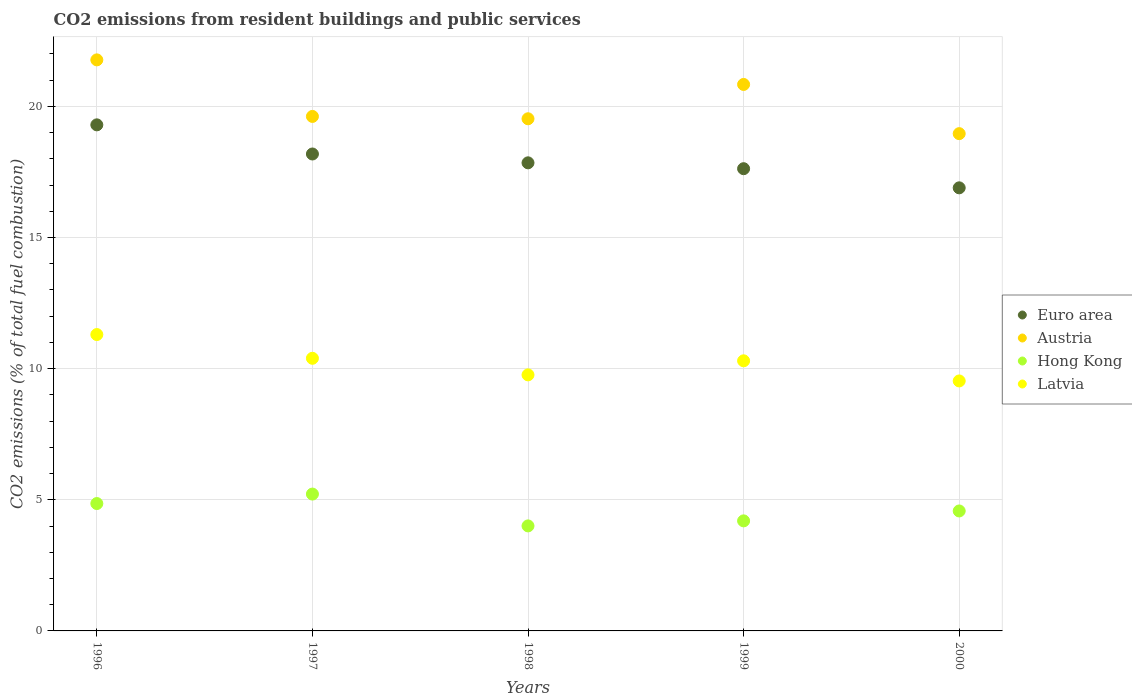How many different coloured dotlines are there?
Your answer should be compact. 4. Is the number of dotlines equal to the number of legend labels?
Offer a very short reply. Yes. What is the total CO2 emitted in Hong Kong in 1999?
Provide a short and direct response. 4.2. Across all years, what is the maximum total CO2 emitted in Latvia?
Offer a very short reply. 11.3. Across all years, what is the minimum total CO2 emitted in Euro area?
Your answer should be compact. 16.89. In which year was the total CO2 emitted in Hong Kong minimum?
Keep it short and to the point. 1998. What is the total total CO2 emitted in Hong Kong in the graph?
Provide a succinct answer. 22.85. What is the difference between the total CO2 emitted in Austria in 1996 and that in 2000?
Provide a succinct answer. 2.81. What is the difference between the total CO2 emitted in Austria in 1999 and the total CO2 emitted in Latvia in 2000?
Make the answer very short. 11.3. What is the average total CO2 emitted in Latvia per year?
Provide a succinct answer. 10.26. In the year 1997, what is the difference between the total CO2 emitted in Hong Kong and total CO2 emitted in Austria?
Offer a very short reply. -14.4. In how many years, is the total CO2 emitted in Latvia greater than 13?
Your answer should be very brief. 0. What is the ratio of the total CO2 emitted in Latvia in 1997 to that in 2000?
Offer a terse response. 1.09. Is the total CO2 emitted in Hong Kong in 1996 less than that in 1998?
Make the answer very short. No. What is the difference between the highest and the second highest total CO2 emitted in Latvia?
Your answer should be very brief. 0.91. What is the difference between the highest and the lowest total CO2 emitted in Latvia?
Provide a succinct answer. 1.77. Is the sum of the total CO2 emitted in Latvia in 1998 and 1999 greater than the maximum total CO2 emitted in Hong Kong across all years?
Offer a terse response. Yes. Is it the case that in every year, the sum of the total CO2 emitted in Austria and total CO2 emitted in Euro area  is greater than the total CO2 emitted in Latvia?
Your answer should be compact. Yes. Does the total CO2 emitted in Latvia monotonically increase over the years?
Your answer should be very brief. No. Is the total CO2 emitted in Euro area strictly greater than the total CO2 emitted in Latvia over the years?
Keep it short and to the point. Yes. Is the total CO2 emitted in Latvia strictly less than the total CO2 emitted in Euro area over the years?
Provide a succinct answer. Yes. How many dotlines are there?
Provide a short and direct response. 4. How many years are there in the graph?
Offer a terse response. 5. Does the graph contain any zero values?
Your response must be concise. No. How many legend labels are there?
Provide a short and direct response. 4. How are the legend labels stacked?
Offer a very short reply. Vertical. What is the title of the graph?
Offer a very short reply. CO2 emissions from resident buildings and public services. What is the label or title of the Y-axis?
Your response must be concise. CO2 emissions (% of total fuel combustion). What is the CO2 emissions (% of total fuel combustion) in Euro area in 1996?
Provide a short and direct response. 19.29. What is the CO2 emissions (% of total fuel combustion) in Austria in 1996?
Make the answer very short. 21.77. What is the CO2 emissions (% of total fuel combustion) in Hong Kong in 1996?
Your answer should be compact. 4.86. What is the CO2 emissions (% of total fuel combustion) of Latvia in 1996?
Your answer should be compact. 11.3. What is the CO2 emissions (% of total fuel combustion) in Euro area in 1997?
Your response must be concise. 18.18. What is the CO2 emissions (% of total fuel combustion) in Austria in 1997?
Offer a very short reply. 19.62. What is the CO2 emissions (% of total fuel combustion) of Hong Kong in 1997?
Keep it short and to the point. 5.22. What is the CO2 emissions (% of total fuel combustion) of Latvia in 1997?
Make the answer very short. 10.39. What is the CO2 emissions (% of total fuel combustion) of Euro area in 1998?
Keep it short and to the point. 17.85. What is the CO2 emissions (% of total fuel combustion) in Austria in 1998?
Give a very brief answer. 19.53. What is the CO2 emissions (% of total fuel combustion) of Hong Kong in 1998?
Provide a succinct answer. 4. What is the CO2 emissions (% of total fuel combustion) of Latvia in 1998?
Offer a terse response. 9.76. What is the CO2 emissions (% of total fuel combustion) of Euro area in 1999?
Give a very brief answer. 17.62. What is the CO2 emissions (% of total fuel combustion) in Austria in 1999?
Make the answer very short. 20.83. What is the CO2 emissions (% of total fuel combustion) of Hong Kong in 1999?
Make the answer very short. 4.2. What is the CO2 emissions (% of total fuel combustion) of Latvia in 1999?
Your answer should be very brief. 10.3. What is the CO2 emissions (% of total fuel combustion) of Euro area in 2000?
Provide a short and direct response. 16.89. What is the CO2 emissions (% of total fuel combustion) in Austria in 2000?
Provide a short and direct response. 18.96. What is the CO2 emissions (% of total fuel combustion) in Hong Kong in 2000?
Your response must be concise. 4.57. What is the CO2 emissions (% of total fuel combustion) of Latvia in 2000?
Offer a terse response. 9.53. Across all years, what is the maximum CO2 emissions (% of total fuel combustion) in Euro area?
Give a very brief answer. 19.29. Across all years, what is the maximum CO2 emissions (% of total fuel combustion) in Austria?
Your answer should be very brief. 21.77. Across all years, what is the maximum CO2 emissions (% of total fuel combustion) of Hong Kong?
Give a very brief answer. 5.22. Across all years, what is the maximum CO2 emissions (% of total fuel combustion) of Latvia?
Provide a short and direct response. 11.3. Across all years, what is the minimum CO2 emissions (% of total fuel combustion) of Euro area?
Give a very brief answer. 16.89. Across all years, what is the minimum CO2 emissions (% of total fuel combustion) in Austria?
Your response must be concise. 18.96. Across all years, what is the minimum CO2 emissions (% of total fuel combustion) of Hong Kong?
Make the answer very short. 4. Across all years, what is the minimum CO2 emissions (% of total fuel combustion) of Latvia?
Offer a very short reply. 9.53. What is the total CO2 emissions (% of total fuel combustion) of Euro area in the graph?
Keep it short and to the point. 89.84. What is the total CO2 emissions (% of total fuel combustion) of Austria in the graph?
Provide a short and direct response. 100.71. What is the total CO2 emissions (% of total fuel combustion) in Hong Kong in the graph?
Offer a terse response. 22.85. What is the total CO2 emissions (% of total fuel combustion) of Latvia in the graph?
Give a very brief answer. 51.28. What is the difference between the CO2 emissions (% of total fuel combustion) in Euro area in 1996 and that in 1997?
Provide a succinct answer. 1.11. What is the difference between the CO2 emissions (% of total fuel combustion) in Austria in 1996 and that in 1997?
Offer a terse response. 2.16. What is the difference between the CO2 emissions (% of total fuel combustion) of Hong Kong in 1996 and that in 1997?
Give a very brief answer. -0.36. What is the difference between the CO2 emissions (% of total fuel combustion) in Latvia in 1996 and that in 1997?
Your answer should be very brief. 0.91. What is the difference between the CO2 emissions (% of total fuel combustion) of Euro area in 1996 and that in 1998?
Offer a very short reply. 1.45. What is the difference between the CO2 emissions (% of total fuel combustion) in Austria in 1996 and that in 1998?
Provide a succinct answer. 2.25. What is the difference between the CO2 emissions (% of total fuel combustion) in Hong Kong in 1996 and that in 1998?
Ensure brevity in your answer.  0.85. What is the difference between the CO2 emissions (% of total fuel combustion) in Latvia in 1996 and that in 1998?
Provide a short and direct response. 1.54. What is the difference between the CO2 emissions (% of total fuel combustion) of Euro area in 1996 and that in 1999?
Provide a short and direct response. 1.67. What is the difference between the CO2 emissions (% of total fuel combustion) in Austria in 1996 and that in 1999?
Keep it short and to the point. 0.94. What is the difference between the CO2 emissions (% of total fuel combustion) in Hong Kong in 1996 and that in 1999?
Make the answer very short. 0.66. What is the difference between the CO2 emissions (% of total fuel combustion) of Euro area in 1996 and that in 2000?
Your response must be concise. 2.4. What is the difference between the CO2 emissions (% of total fuel combustion) of Austria in 1996 and that in 2000?
Offer a very short reply. 2.81. What is the difference between the CO2 emissions (% of total fuel combustion) in Hong Kong in 1996 and that in 2000?
Give a very brief answer. 0.28. What is the difference between the CO2 emissions (% of total fuel combustion) in Latvia in 1996 and that in 2000?
Keep it short and to the point. 1.77. What is the difference between the CO2 emissions (% of total fuel combustion) in Euro area in 1997 and that in 1998?
Your answer should be very brief. 0.34. What is the difference between the CO2 emissions (% of total fuel combustion) of Austria in 1997 and that in 1998?
Keep it short and to the point. 0.09. What is the difference between the CO2 emissions (% of total fuel combustion) in Hong Kong in 1997 and that in 1998?
Give a very brief answer. 1.21. What is the difference between the CO2 emissions (% of total fuel combustion) in Latvia in 1997 and that in 1998?
Ensure brevity in your answer.  0.63. What is the difference between the CO2 emissions (% of total fuel combustion) of Euro area in 1997 and that in 1999?
Offer a terse response. 0.56. What is the difference between the CO2 emissions (% of total fuel combustion) in Austria in 1997 and that in 1999?
Keep it short and to the point. -1.22. What is the difference between the CO2 emissions (% of total fuel combustion) of Hong Kong in 1997 and that in 1999?
Keep it short and to the point. 1.02. What is the difference between the CO2 emissions (% of total fuel combustion) of Latvia in 1997 and that in 1999?
Provide a succinct answer. 0.1. What is the difference between the CO2 emissions (% of total fuel combustion) in Euro area in 1997 and that in 2000?
Provide a short and direct response. 1.29. What is the difference between the CO2 emissions (% of total fuel combustion) of Austria in 1997 and that in 2000?
Your response must be concise. 0.66. What is the difference between the CO2 emissions (% of total fuel combustion) in Hong Kong in 1997 and that in 2000?
Give a very brief answer. 0.64. What is the difference between the CO2 emissions (% of total fuel combustion) of Latvia in 1997 and that in 2000?
Offer a terse response. 0.86. What is the difference between the CO2 emissions (% of total fuel combustion) of Euro area in 1998 and that in 1999?
Offer a terse response. 0.22. What is the difference between the CO2 emissions (% of total fuel combustion) in Austria in 1998 and that in 1999?
Ensure brevity in your answer.  -1.31. What is the difference between the CO2 emissions (% of total fuel combustion) of Hong Kong in 1998 and that in 1999?
Make the answer very short. -0.19. What is the difference between the CO2 emissions (% of total fuel combustion) of Latvia in 1998 and that in 1999?
Make the answer very short. -0.54. What is the difference between the CO2 emissions (% of total fuel combustion) of Euro area in 1998 and that in 2000?
Give a very brief answer. 0.95. What is the difference between the CO2 emissions (% of total fuel combustion) of Austria in 1998 and that in 2000?
Provide a succinct answer. 0.57. What is the difference between the CO2 emissions (% of total fuel combustion) in Hong Kong in 1998 and that in 2000?
Ensure brevity in your answer.  -0.57. What is the difference between the CO2 emissions (% of total fuel combustion) in Latvia in 1998 and that in 2000?
Provide a short and direct response. 0.23. What is the difference between the CO2 emissions (% of total fuel combustion) of Euro area in 1999 and that in 2000?
Make the answer very short. 0.73. What is the difference between the CO2 emissions (% of total fuel combustion) in Austria in 1999 and that in 2000?
Your answer should be compact. 1.88. What is the difference between the CO2 emissions (% of total fuel combustion) of Hong Kong in 1999 and that in 2000?
Your answer should be compact. -0.38. What is the difference between the CO2 emissions (% of total fuel combustion) of Latvia in 1999 and that in 2000?
Offer a very short reply. 0.77. What is the difference between the CO2 emissions (% of total fuel combustion) of Euro area in 1996 and the CO2 emissions (% of total fuel combustion) of Austria in 1997?
Your answer should be compact. -0.32. What is the difference between the CO2 emissions (% of total fuel combustion) of Euro area in 1996 and the CO2 emissions (% of total fuel combustion) of Hong Kong in 1997?
Make the answer very short. 14.08. What is the difference between the CO2 emissions (% of total fuel combustion) of Euro area in 1996 and the CO2 emissions (% of total fuel combustion) of Latvia in 1997?
Keep it short and to the point. 8.9. What is the difference between the CO2 emissions (% of total fuel combustion) in Austria in 1996 and the CO2 emissions (% of total fuel combustion) in Hong Kong in 1997?
Your answer should be very brief. 16.55. What is the difference between the CO2 emissions (% of total fuel combustion) of Austria in 1996 and the CO2 emissions (% of total fuel combustion) of Latvia in 1997?
Offer a terse response. 11.38. What is the difference between the CO2 emissions (% of total fuel combustion) of Hong Kong in 1996 and the CO2 emissions (% of total fuel combustion) of Latvia in 1997?
Provide a succinct answer. -5.54. What is the difference between the CO2 emissions (% of total fuel combustion) of Euro area in 1996 and the CO2 emissions (% of total fuel combustion) of Austria in 1998?
Offer a very short reply. -0.23. What is the difference between the CO2 emissions (% of total fuel combustion) of Euro area in 1996 and the CO2 emissions (% of total fuel combustion) of Hong Kong in 1998?
Offer a very short reply. 15.29. What is the difference between the CO2 emissions (% of total fuel combustion) of Euro area in 1996 and the CO2 emissions (% of total fuel combustion) of Latvia in 1998?
Keep it short and to the point. 9.53. What is the difference between the CO2 emissions (% of total fuel combustion) in Austria in 1996 and the CO2 emissions (% of total fuel combustion) in Hong Kong in 1998?
Ensure brevity in your answer.  17.77. What is the difference between the CO2 emissions (% of total fuel combustion) of Austria in 1996 and the CO2 emissions (% of total fuel combustion) of Latvia in 1998?
Provide a succinct answer. 12.01. What is the difference between the CO2 emissions (% of total fuel combustion) in Hong Kong in 1996 and the CO2 emissions (% of total fuel combustion) in Latvia in 1998?
Keep it short and to the point. -4.91. What is the difference between the CO2 emissions (% of total fuel combustion) of Euro area in 1996 and the CO2 emissions (% of total fuel combustion) of Austria in 1999?
Offer a very short reply. -1.54. What is the difference between the CO2 emissions (% of total fuel combustion) of Euro area in 1996 and the CO2 emissions (% of total fuel combustion) of Hong Kong in 1999?
Keep it short and to the point. 15.1. What is the difference between the CO2 emissions (% of total fuel combustion) of Euro area in 1996 and the CO2 emissions (% of total fuel combustion) of Latvia in 1999?
Provide a short and direct response. 9. What is the difference between the CO2 emissions (% of total fuel combustion) of Austria in 1996 and the CO2 emissions (% of total fuel combustion) of Hong Kong in 1999?
Keep it short and to the point. 17.58. What is the difference between the CO2 emissions (% of total fuel combustion) of Austria in 1996 and the CO2 emissions (% of total fuel combustion) of Latvia in 1999?
Your response must be concise. 11.47. What is the difference between the CO2 emissions (% of total fuel combustion) in Hong Kong in 1996 and the CO2 emissions (% of total fuel combustion) in Latvia in 1999?
Ensure brevity in your answer.  -5.44. What is the difference between the CO2 emissions (% of total fuel combustion) of Euro area in 1996 and the CO2 emissions (% of total fuel combustion) of Austria in 2000?
Give a very brief answer. 0.34. What is the difference between the CO2 emissions (% of total fuel combustion) of Euro area in 1996 and the CO2 emissions (% of total fuel combustion) of Hong Kong in 2000?
Offer a very short reply. 14.72. What is the difference between the CO2 emissions (% of total fuel combustion) of Euro area in 1996 and the CO2 emissions (% of total fuel combustion) of Latvia in 2000?
Offer a terse response. 9.76. What is the difference between the CO2 emissions (% of total fuel combustion) of Austria in 1996 and the CO2 emissions (% of total fuel combustion) of Hong Kong in 2000?
Provide a short and direct response. 17.2. What is the difference between the CO2 emissions (% of total fuel combustion) of Austria in 1996 and the CO2 emissions (% of total fuel combustion) of Latvia in 2000?
Your answer should be compact. 12.24. What is the difference between the CO2 emissions (% of total fuel combustion) of Hong Kong in 1996 and the CO2 emissions (% of total fuel combustion) of Latvia in 2000?
Give a very brief answer. -4.67. What is the difference between the CO2 emissions (% of total fuel combustion) of Euro area in 1997 and the CO2 emissions (% of total fuel combustion) of Austria in 1998?
Offer a very short reply. -1.34. What is the difference between the CO2 emissions (% of total fuel combustion) in Euro area in 1997 and the CO2 emissions (% of total fuel combustion) in Hong Kong in 1998?
Your answer should be very brief. 14.18. What is the difference between the CO2 emissions (% of total fuel combustion) of Euro area in 1997 and the CO2 emissions (% of total fuel combustion) of Latvia in 1998?
Make the answer very short. 8.42. What is the difference between the CO2 emissions (% of total fuel combustion) of Austria in 1997 and the CO2 emissions (% of total fuel combustion) of Hong Kong in 1998?
Provide a succinct answer. 15.61. What is the difference between the CO2 emissions (% of total fuel combustion) of Austria in 1997 and the CO2 emissions (% of total fuel combustion) of Latvia in 1998?
Your answer should be compact. 9.85. What is the difference between the CO2 emissions (% of total fuel combustion) of Hong Kong in 1997 and the CO2 emissions (% of total fuel combustion) of Latvia in 1998?
Make the answer very short. -4.54. What is the difference between the CO2 emissions (% of total fuel combustion) of Euro area in 1997 and the CO2 emissions (% of total fuel combustion) of Austria in 1999?
Ensure brevity in your answer.  -2.65. What is the difference between the CO2 emissions (% of total fuel combustion) of Euro area in 1997 and the CO2 emissions (% of total fuel combustion) of Hong Kong in 1999?
Provide a succinct answer. 13.99. What is the difference between the CO2 emissions (% of total fuel combustion) of Euro area in 1997 and the CO2 emissions (% of total fuel combustion) of Latvia in 1999?
Offer a very short reply. 7.89. What is the difference between the CO2 emissions (% of total fuel combustion) of Austria in 1997 and the CO2 emissions (% of total fuel combustion) of Hong Kong in 1999?
Offer a very short reply. 15.42. What is the difference between the CO2 emissions (% of total fuel combustion) in Austria in 1997 and the CO2 emissions (% of total fuel combustion) in Latvia in 1999?
Make the answer very short. 9.32. What is the difference between the CO2 emissions (% of total fuel combustion) in Hong Kong in 1997 and the CO2 emissions (% of total fuel combustion) in Latvia in 1999?
Keep it short and to the point. -5.08. What is the difference between the CO2 emissions (% of total fuel combustion) in Euro area in 1997 and the CO2 emissions (% of total fuel combustion) in Austria in 2000?
Provide a short and direct response. -0.78. What is the difference between the CO2 emissions (% of total fuel combustion) in Euro area in 1997 and the CO2 emissions (% of total fuel combustion) in Hong Kong in 2000?
Ensure brevity in your answer.  13.61. What is the difference between the CO2 emissions (% of total fuel combustion) in Euro area in 1997 and the CO2 emissions (% of total fuel combustion) in Latvia in 2000?
Your answer should be very brief. 8.65. What is the difference between the CO2 emissions (% of total fuel combustion) in Austria in 1997 and the CO2 emissions (% of total fuel combustion) in Hong Kong in 2000?
Provide a short and direct response. 15.04. What is the difference between the CO2 emissions (% of total fuel combustion) in Austria in 1997 and the CO2 emissions (% of total fuel combustion) in Latvia in 2000?
Provide a succinct answer. 10.08. What is the difference between the CO2 emissions (% of total fuel combustion) of Hong Kong in 1997 and the CO2 emissions (% of total fuel combustion) of Latvia in 2000?
Offer a very short reply. -4.31. What is the difference between the CO2 emissions (% of total fuel combustion) of Euro area in 1998 and the CO2 emissions (% of total fuel combustion) of Austria in 1999?
Provide a short and direct response. -2.99. What is the difference between the CO2 emissions (% of total fuel combustion) of Euro area in 1998 and the CO2 emissions (% of total fuel combustion) of Hong Kong in 1999?
Your answer should be very brief. 13.65. What is the difference between the CO2 emissions (% of total fuel combustion) of Euro area in 1998 and the CO2 emissions (% of total fuel combustion) of Latvia in 1999?
Ensure brevity in your answer.  7.55. What is the difference between the CO2 emissions (% of total fuel combustion) of Austria in 1998 and the CO2 emissions (% of total fuel combustion) of Hong Kong in 1999?
Make the answer very short. 15.33. What is the difference between the CO2 emissions (% of total fuel combustion) of Austria in 1998 and the CO2 emissions (% of total fuel combustion) of Latvia in 1999?
Ensure brevity in your answer.  9.23. What is the difference between the CO2 emissions (% of total fuel combustion) in Hong Kong in 1998 and the CO2 emissions (% of total fuel combustion) in Latvia in 1999?
Give a very brief answer. -6.29. What is the difference between the CO2 emissions (% of total fuel combustion) of Euro area in 1998 and the CO2 emissions (% of total fuel combustion) of Austria in 2000?
Make the answer very short. -1.11. What is the difference between the CO2 emissions (% of total fuel combustion) in Euro area in 1998 and the CO2 emissions (% of total fuel combustion) in Hong Kong in 2000?
Ensure brevity in your answer.  13.27. What is the difference between the CO2 emissions (% of total fuel combustion) of Euro area in 1998 and the CO2 emissions (% of total fuel combustion) of Latvia in 2000?
Give a very brief answer. 8.32. What is the difference between the CO2 emissions (% of total fuel combustion) in Austria in 1998 and the CO2 emissions (% of total fuel combustion) in Hong Kong in 2000?
Ensure brevity in your answer.  14.95. What is the difference between the CO2 emissions (% of total fuel combustion) of Austria in 1998 and the CO2 emissions (% of total fuel combustion) of Latvia in 2000?
Provide a succinct answer. 10. What is the difference between the CO2 emissions (% of total fuel combustion) in Hong Kong in 1998 and the CO2 emissions (% of total fuel combustion) in Latvia in 2000?
Your answer should be very brief. -5.53. What is the difference between the CO2 emissions (% of total fuel combustion) of Euro area in 1999 and the CO2 emissions (% of total fuel combustion) of Austria in 2000?
Your answer should be compact. -1.34. What is the difference between the CO2 emissions (% of total fuel combustion) in Euro area in 1999 and the CO2 emissions (% of total fuel combustion) in Hong Kong in 2000?
Provide a short and direct response. 13.05. What is the difference between the CO2 emissions (% of total fuel combustion) in Euro area in 1999 and the CO2 emissions (% of total fuel combustion) in Latvia in 2000?
Give a very brief answer. 8.09. What is the difference between the CO2 emissions (% of total fuel combustion) in Austria in 1999 and the CO2 emissions (% of total fuel combustion) in Hong Kong in 2000?
Provide a short and direct response. 16.26. What is the difference between the CO2 emissions (% of total fuel combustion) of Austria in 1999 and the CO2 emissions (% of total fuel combustion) of Latvia in 2000?
Offer a terse response. 11.3. What is the difference between the CO2 emissions (% of total fuel combustion) of Hong Kong in 1999 and the CO2 emissions (% of total fuel combustion) of Latvia in 2000?
Your answer should be very brief. -5.33. What is the average CO2 emissions (% of total fuel combustion) in Euro area per year?
Ensure brevity in your answer.  17.97. What is the average CO2 emissions (% of total fuel combustion) in Austria per year?
Provide a short and direct response. 20.14. What is the average CO2 emissions (% of total fuel combustion) of Hong Kong per year?
Make the answer very short. 4.57. What is the average CO2 emissions (% of total fuel combustion) in Latvia per year?
Offer a terse response. 10.26. In the year 1996, what is the difference between the CO2 emissions (% of total fuel combustion) in Euro area and CO2 emissions (% of total fuel combustion) in Austria?
Your answer should be compact. -2.48. In the year 1996, what is the difference between the CO2 emissions (% of total fuel combustion) in Euro area and CO2 emissions (% of total fuel combustion) in Hong Kong?
Offer a terse response. 14.44. In the year 1996, what is the difference between the CO2 emissions (% of total fuel combustion) of Euro area and CO2 emissions (% of total fuel combustion) of Latvia?
Keep it short and to the point. 8. In the year 1996, what is the difference between the CO2 emissions (% of total fuel combustion) of Austria and CO2 emissions (% of total fuel combustion) of Hong Kong?
Ensure brevity in your answer.  16.92. In the year 1996, what is the difference between the CO2 emissions (% of total fuel combustion) in Austria and CO2 emissions (% of total fuel combustion) in Latvia?
Provide a succinct answer. 10.47. In the year 1996, what is the difference between the CO2 emissions (% of total fuel combustion) in Hong Kong and CO2 emissions (% of total fuel combustion) in Latvia?
Keep it short and to the point. -6.44. In the year 1997, what is the difference between the CO2 emissions (% of total fuel combustion) in Euro area and CO2 emissions (% of total fuel combustion) in Austria?
Your answer should be compact. -1.43. In the year 1997, what is the difference between the CO2 emissions (% of total fuel combustion) of Euro area and CO2 emissions (% of total fuel combustion) of Hong Kong?
Provide a short and direct response. 12.97. In the year 1997, what is the difference between the CO2 emissions (% of total fuel combustion) in Euro area and CO2 emissions (% of total fuel combustion) in Latvia?
Your response must be concise. 7.79. In the year 1997, what is the difference between the CO2 emissions (% of total fuel combustion) of Austria and CO2 emissions (% of total fuel combustion) of Hong Kong?
Your response must be concise. 14.4. In the year 1997, what is the difference between the CO2 emissions (% of total fuel combustion) in Austria and CO2 emissions (% of total fuel combustion) in Latvia?
Keep it short and to the point. 9.22. In the year 1997, what is the difference between the CO2 emissions (% of total fuel combustion) in Hong Kong and CO2 emissions (% of total fuel combustion) in Latvia?
Provide a short and direct response. -5.18. In the year 1998, what is the difference between the CO2 emissions (% of total fuel combustion) in Euro area and CO2 emissions (% of total fuel combustion) in Austria?
Provide a short and direct response. -1.68. In the year 1998, what is the difference between the CO2 emissions (% of total fuel combustion) in Euro area and CO2 emissions (% of total fuel combustion) in Hong Kong?
Ensure brevity in your answer.  13.84. In the year 1998, what is the difference between the CO2 emissions (% of total fuel combustion) in Euro area and CO2 emissions (% of total fuel combustion) in Latvia?
Keep it short and to the point. 8.08. In the year 1998, what is the difference between the CO2 emissions (% of total fuel combustion) of Austria and CO2 emissions (% of total fuel combustion) of Hong Kong?
Give a very brief answer. 15.52. In the year 1998, what is the difference between the CO2 emissions (% of total fuel combustion) of Austria and CO2 emissions (% of total fuel combustion) of Latvia?
Provide a succinct answer. 9.76. In the year 1998, what is the difference between the CO2 emissions (% of total fuel combustion) in Hong Kong and CO2 emissions (% of total fuel combustion) in Latvia?
Provide a short and direct response. -5.76. In the year 1999, what is the difference between the CO2 emissions (% of total fuel combustion) of Euro area and CO2 emissions (% of total fuel combustion) of Austria?
Offer a terse response. -3.21. In the year 1999, what is the difference between the CO2 emissions (% of total fuel combustion) in Euro area and CO2 emissions (% of total fuel combustion) in Hong Kong?
Ensure brevity in your answer.  13.43. In the year 1999, what is the difference between the CO2 emissions (% of total fuel combustion) in Euro area and CO2 emissions (% of total fuel combustion) in Latvia?
Make the answer very short. 7.32. In the year 1999, what is the difference between the CO2 emissions (% of total fuel combustion) of Austria and CO2 emissions (% of total fuel combustion) of Hong Kong?
Provide a short and direct response. 16.64. In the year 1999, what is the difference between the CO2 emissions (% of total fuel combustion) of Austria and CO2 emissions (% of total fuel combustion) of Latvia?
Give a very brief answer. 10.54. In the year 1999, what is the difference between the CO2 emissions (% of total fuel combustion) in Hong Kong and CO2 emissions (% of total fuel combustion) in Latvia?
Offer a terse response. -6.1. In the year 2000, what is the difference between the CO2 emissions (% of total fuel combustion) of Euro area and CO2 emissions (% of total fuel combustion) of Austria?
Make the answer very short. -2.07. In the year 2000, what is the difference between the CO2 emissions (% of total fuel combustion) of Euro area and CO2 emissions (% of total fuel combustion) of Hong Kong?
Provide a short and direct response. 12.32. In the year 2000, what is the difference between the CO2 emissions (% of total fuel combustion) of Euro area and CO2 emissions (% of total fuel combustion) of Latvia?
Offer a very short reply. 7.36. In the year 2000, what is the difference between the CO2 emissions (% of total fuel combustion) of Austria and CO2 emissions (% of total fuel combustion) of Hong Kong?
Offer a terse response. 14.39. In the year 2000, what is the difference between the CO2 emissions (% of total fuel combustion) in Austria and CO2 emissions (% of total fuel combustion) in Latvia?
Your answer should be very brief. 9.43. In the year 2000, what is the difference between the CO2 emissions (% of total fuel combustion) in Hong Kong and CO2 emissions (% of total fuel combustion) in Latvia?
Your answer should be compact. -4.96. What is the ratio of the CO2 emissions (% of total fuel combustion) in Euro area in 1996 to that in 1997?
Make the answer very short. 1.06. What is the ratio of the CO2 emissions (% of total fuel combustion) in Austria in 1996 to that in 1997?
Ensure brevity in your answer.  1.11. What is the ratio of the CO2 emissions (% of total fuel combustion) in Hong Kong in 1996 to that in 1997?
Your answer should be compact. 0.93. What is the ratio of the CO2 emissions (% of total fuel combustion) in Latvia in 1996 to that in 1997?
Offer a terse response. 1.09. What is the ratio of the CO2 emissions (% of total fuel combustion) in Euro area in 1996 to that in 1998?
Offer a very short reply. 1.08. What is the ratio of the CO2 emissions (% of total fuel combustion) of Austria in 1996 to that in 1998?
Provide a short and direct response. 1.11. What is the ratio of the CO2 emissions (% of total fuel combustion) in Hong Kong in 1996 to that in 1998?
Your response must be concise. 1.21. What is the ratio of the CO2 emissions (% of total fuel combustion) of Latvia in 1996 to that in 1998?
Your answer should be very brief. 1.16. What is the ratio of the CO2 emissions (% of total fuel combustion) of Euro area in 1996 to that in 1999?
Offer a very short reply. 1.09. What is the ratio of the CO2 emissions (% of total fuel combustion) of Austria in 1996 to that in 1999?
Offer a very short reply. 1.04. What is the ratio of the CO2 emissions (% of total fuel combustion) in Hong Kong in 1996 to that in 1999?
Your response must be concise. 1.16. What is the ratio of the CO2 emissions (% of total fuel combustion) in Latvia in 1996 to that in 1999?
Ensure brevity in your answer.  1.1. What is the ratio of the CO2 emissions (% of total fuel combustion) in Euro area in 1996 to that in 2000?
Give a very brief answer. 1.14. What is the ratio of the CO2 emissions (% of total fuel combustion) in Austria in 1996 to that in 2000?
Offer a very short reply. 1.15. What is the ratio of the CO2 emissions (% of total fuel combustion) in Hong Kong in 1996 to that in 2000?
Ensure brevity in your answer.  1.06. What is the ratio of the CO2 emissions (% of total fuel combustion) of Latvia in 1996 to that in 2000?
Your answer should be very brief. 1.19. What is the ratio of the CO2 emissions (% of total fuel combustion) of Euro area in 1997 to that in 1998?
Your answer should be compact. 1.02. What is the ratio of the CO2 emissions (% of total fuel combustion) of Hong Kong in 1997 to that in 1998?
Give a very brief answer. 1.3. What is the ratio of the CO2 emissions (% of total fuel combustion) in Latvia in 1997 to that in 1998?
Offer a terse response. 1.06. What is the ratio of the CO2 emissions (% of total fuel combustion) in Euro area in 1997 to that in 1999?
Your answer should be compact. 1.03. What is the ratio of the CO2 emissions (% of total fuel combustion) of Austria in 1997 to that in 1999?
Keep it short and to the point. 0.94. What is the ratio of the CO2 emissions (% of total fuel combustion) of Hong Kong in 1997 to that in 1999?
Your answer should be compact. 1.24. What is the ratio of the CO2 emissions (% of total fuel combustion) in Latvia in 1997 to that in 1999?
Make the answer very short. 1.01. What is the ratio of the CO2 emissions (% of total fuel combustion) in Euro area in 1997 to that in 2000?
Offer a very short reply. 1.08. What is the ratio of the CO2 emissions (% of total fuel combustion) of Austria in 1997 to that in 2000?
Offer a very short reply. 1.03. What is the ratio of the CO2 emissions (% of total fuel combustion) in Hong Kong in 1997 to that in 2000?
Keep it short and to the point. 1.14. What is the ratio of the CO2 emissions (% of total fuel combustion) in Latvia in 1997 to that in 2000?
Provide a short and direct response. 1.09. What is the ratio of the CO2 emissions (% of total fuel combustion) in Euro area in 1998 to that in 1999?
Give a very brief answer. 1.01. What is the ratio of the CO2 emissions (% of total fuel combustion) in Austria in 1998 to that in 1999?
Make the answer very short. 0.94. What is the ratio of the CO2 emissions (% of total fuel combustion) of Hong Kong in 1998 to that in 1999?
Provide a short and direct response. 0.95. What is the ratio of the CO2 emissions (% of total fuel combustion) of Latvia in 1998 to that in 1999?
Your response must be concise. 0.95. What is the ratio of the CO2 emissions (% of total fuel combustion) in Euro area in 1998 to that in 2000?
Offer a very short reply. 1.06. What is the ratio of the CO2 emissions (% of total fuel combustion) in Austria in 1998 to that in 2000?
Provide a short and direct response. 1.03. What is the ratio of the CO2 emissions (% of total fuel combustion) in Hong Kong in 1998 to that in 2000?
Offer a terse response. 0.88. What is the ratio of the CO2 emissions (% of total fuel combustion) of Latvia in 1998 to that in 2000?
Your answer should be very brief. 1.02. What is the ratio of the CO2 emissions (% of total fuel combustion) of Euro area in 1999 to that in 2000?
Offer a very short reply. 1.04. What is the ratio of the CO2 emissions (% of total fuel combustion) of Austria in 1999 to that in 2000?
Keep it short and to the point. 1.1. What is the ratio of the CO2 emissions (% of total fuel combustion) of Hong Kong in 1999 to that in 2000?
Ensure brevity in your answer.  0.92. What is the ratio of the CO2 emissions (% of total fuel combustion) in Latvia in 1999 to that in 2000?
Give a very brief answer. 1.08. What is the difference between the highest and the second highest CO2 emissions (% of total fuel combustion) of Euro area?
Offer a terse response. 1.11. What is the difference between the highest and the second highest CO2 emissions (% of total fuel combustion) of Austria?
Make the answer very short. 0.94. What is the difference between the highest and the second highest CO2 emissions (% of total fuel combustion) of Hong Kong?
Offer a very short reply. 0.36. What is the difference between the highest and the second highest CO2 emissions (% of total fuel combustion) of Latvia?
Your answer should be compact. 0.91. What is the difference between the highest and the lowest CO2 emissions (% of total fuel combustion) in Euro area?
Give a very brief answer. 2.4. What is the difference between the highest and the lowest CO2 emissions (% of total fuel combustion) in Austria?
Provide a short and direct response. 2.81. What is the difference between the highest and the lowest CO2 emissions (% of total fuel combustion) of Hong Kong?
Keep it short and to the point. 1.21. What is the difference between the highest and the lowest CO2 emissions (% of total fuel combustion) of Latvia?
Provide a short and direct response. 1.77. 